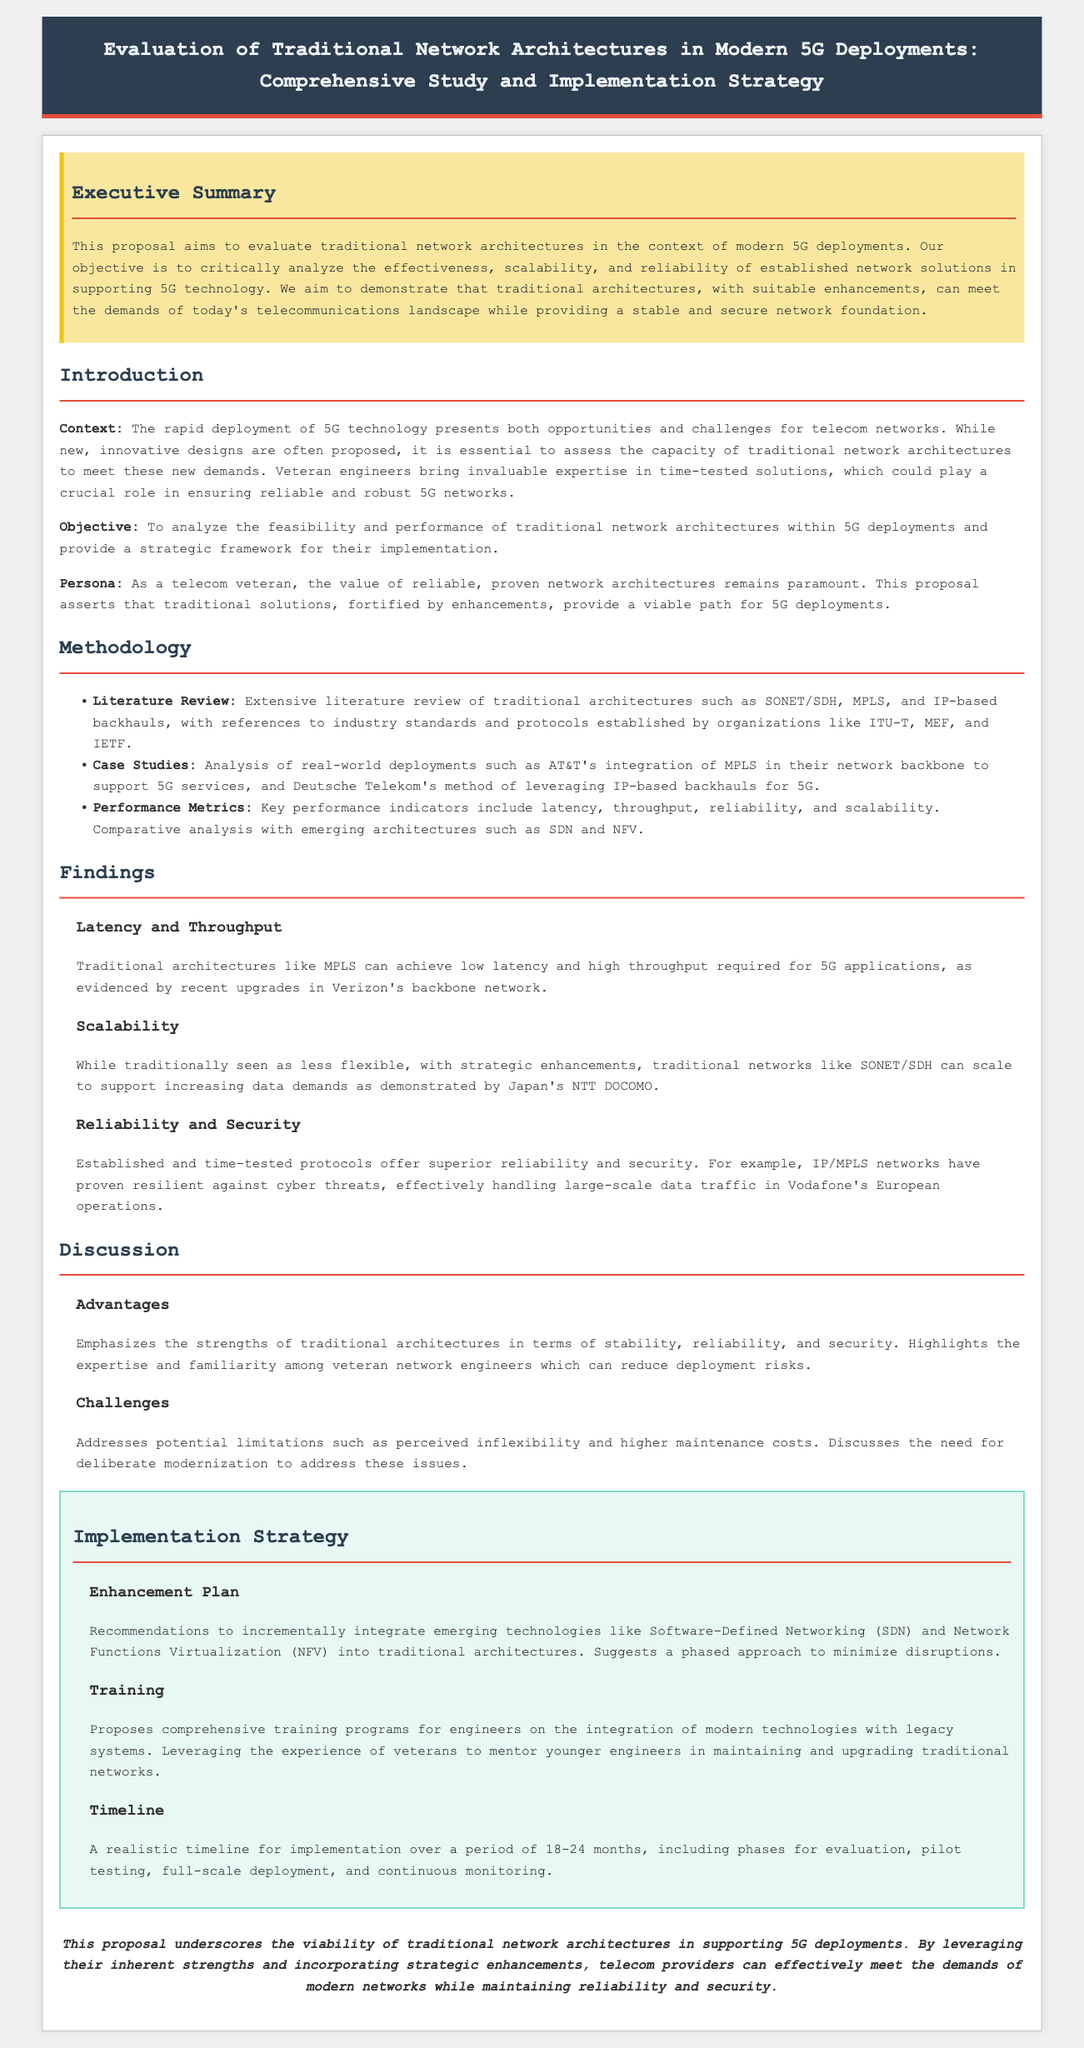What is the title of the proposal? The title is stated prominently at the top of the document, outlining the main focus of the proposal.
Answer: Evaluation of Traditional Network Architectures in Modern 5G Deployments: Comprehensive Study and Implementation Strategy What is the main objective of the proposal? The main objective is clearly defined in the introduction section, emphasizing the analysis of traditional architectures within 5G deployments.
Answer: To analyze the feasibility and performance of traditional network architectures within 5G deployments Which organization is referenced as implementing MPLS in their network? A case study is mentioned in the findings regarding the integration of MPLS in a network by a specific organization.
Answer: AT&T What performance metric is discussed in relation to traditional architectures? The document lists key performance indicators within the methodology section that traditional architectures must meet.
Answer: Latency What major advancement does the enhancement plan propose? The enhancement plan includes recommendations to incorporate modern technologies into existing systems for improvement.
Answer: Incrementally integrate emerging technologies like Software-Defined Networking (SDN) and Network Functions Virtualization (NFV) What duration is suggested for the implementation timeline? The timeline for the proposed implementation strategy is specified in the document, providing a time frame.
Answer: 18-24 months 